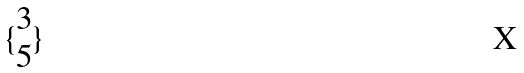Convert formula to latex. <formula><loc_0><loc_0><loc_500><loc_500>\{ \begin{matrix} 3 \\ 5 \end{matrix} \}</formula> 